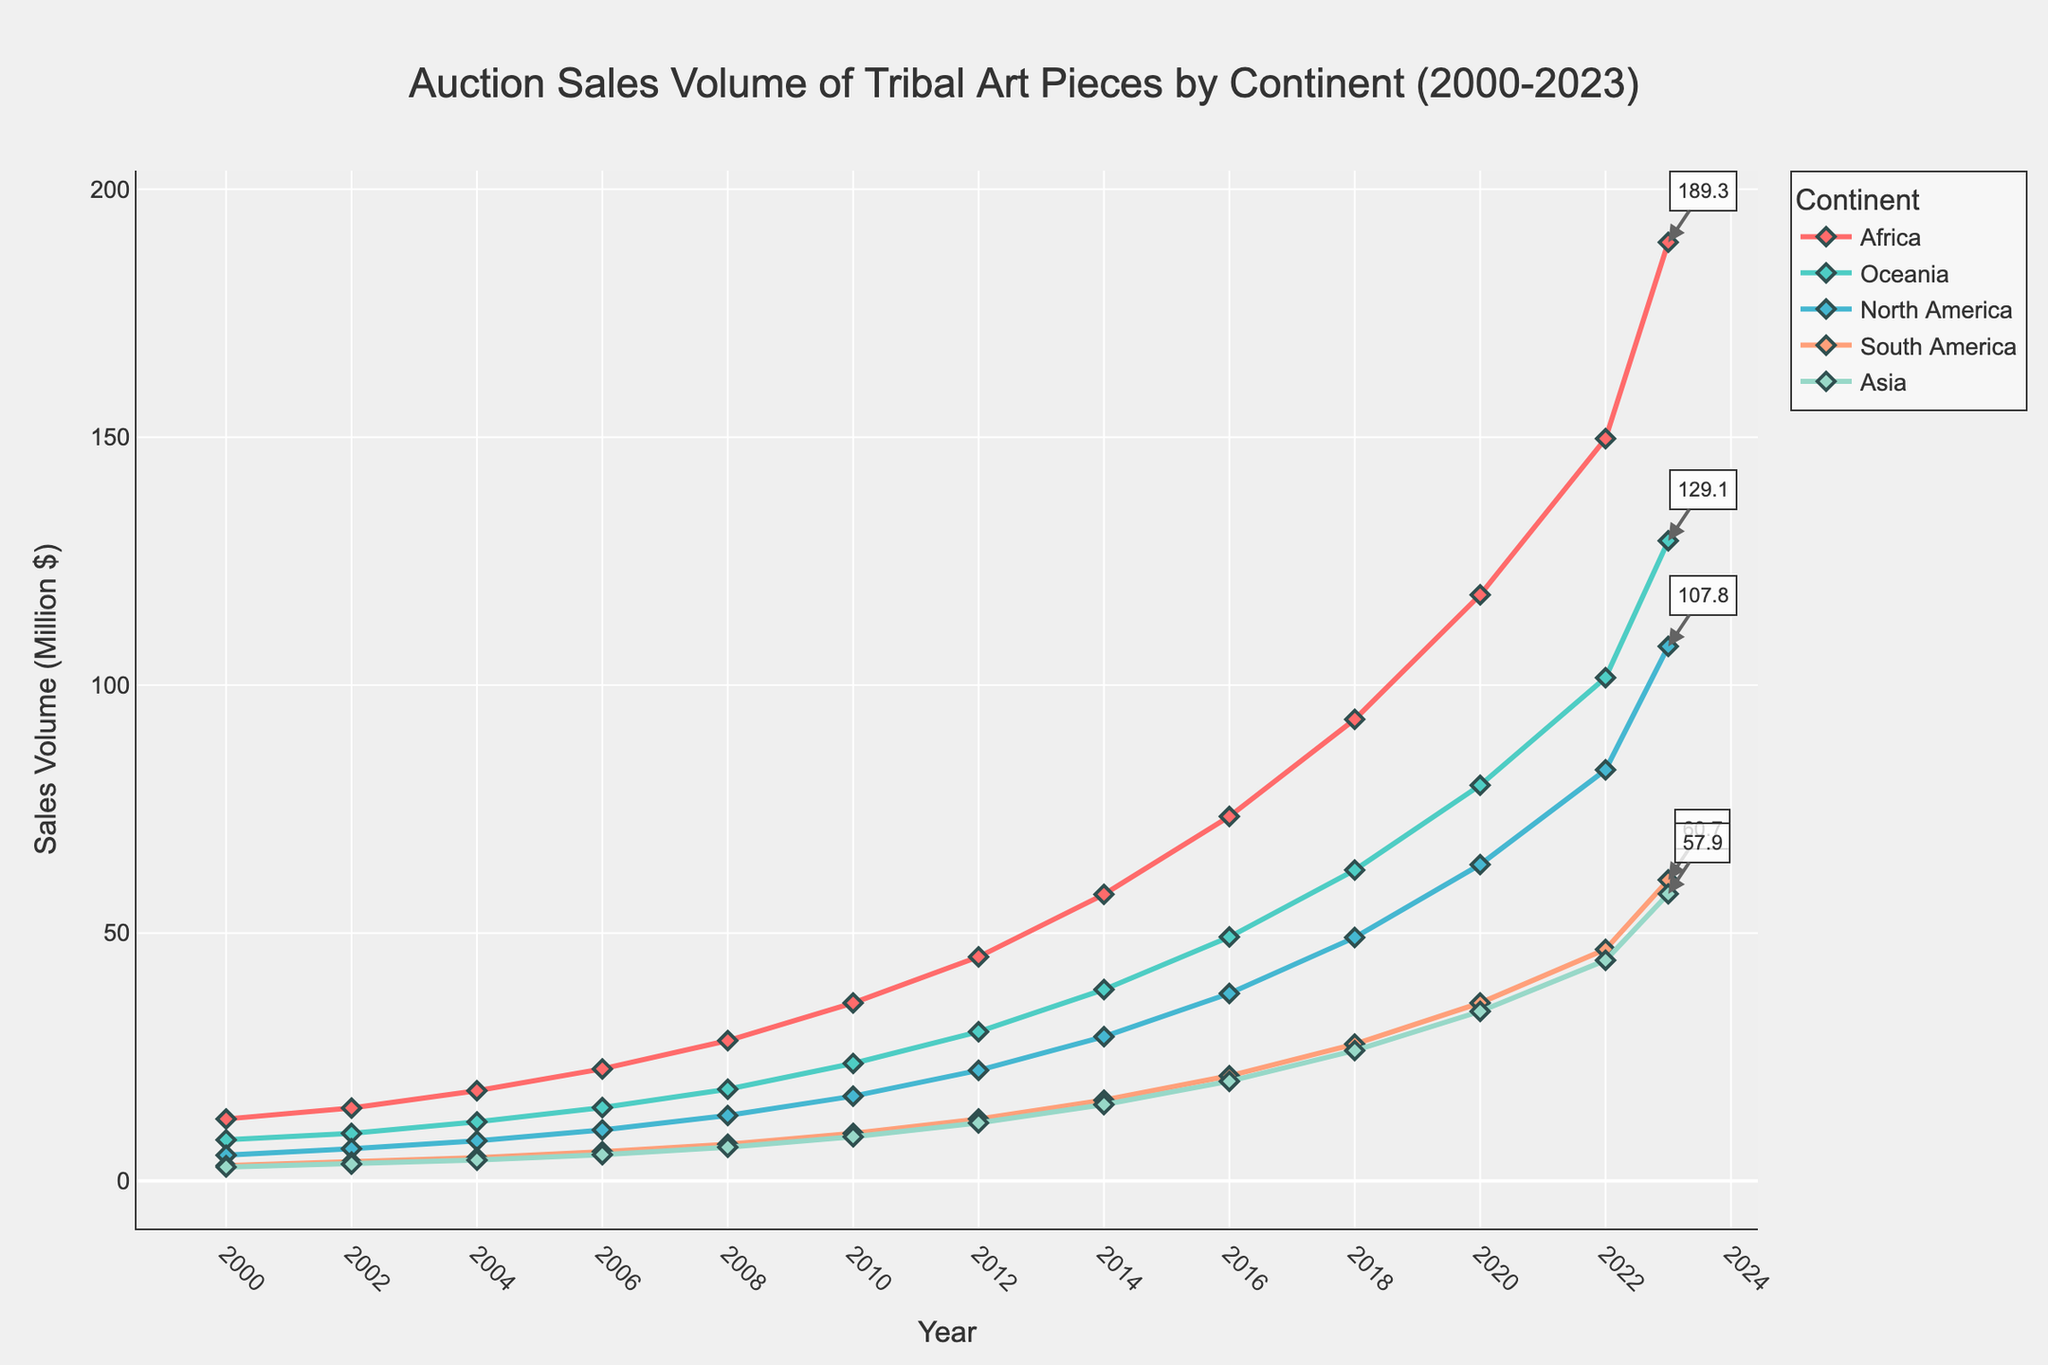What year saw the highest sales volume in North America? North America reaches the highest sales volume in 2023. Look at the peak of the North America line, marked by a diamond marker.
Answer: 2023 By how much did the sales volume of African tribal art increase from 2000 to 2023? The sales volume increased from 12.5 in 2000 to 189.3 in 2023. The difference is 189.3 - 12.5 = 176.8.
Answer: 176.8 Which continent had the slowest growth in sales volume from 2000 to 2023? By comparing the starting and ending points of the lines, Asia had the slowest growth, increasing from 2.8 to 57.9.
Answer: Asia Compare the auction sales volume of Oceania and South America in 2016. Which was higher and by how much? In 2016, Oceania had a sales volume of 49.2 and South America had 21.2. The difference is 49.2 - 21.2 = 28.0.
Answer: Oceania, by 28.0 What is the overall trend for sales volume in all continents from 2000 to 2023? The overall trend for all continents is an increase in sales volume over the years. Each line on the chart shows a rising pattern from left to right.
Answer: Increasing What is the combined sales volume of African and Oceanic tribal art in 2020? In 2020, Africa had 118.2 and Oceania had 79.8. Adding these gives 118.2 + 79.8 = 198.0.
Answer: 198.0 How many continents surpassed the 100-million sales volume mark by 2023? By examining the endpoint of each line, Africa, Oceania, and North America surpassed 100 million in 2023.
Answer: 3 Which continent had the steepest increase in auction sales volume between 2018 and 2020? The steepest increase can be found by comparing the slopes between 2018 and 2020. Africa had the steepest increase from 93.1 to 118.2.
Answer: Africa Between which consecutive years did South America see the highest sales volume increase? By checking the line for South America, the highest increase was between 2022 and 2023, from 46.7 to 60.7.
Answer: 2022 to 2023 Among all the continents, which one consistently had the lowest auction sales volume every year from 2000 to 2023? By observing the lowest line throughout all years, Asia consistently had the lowest sales volume.
Answer: Asia 